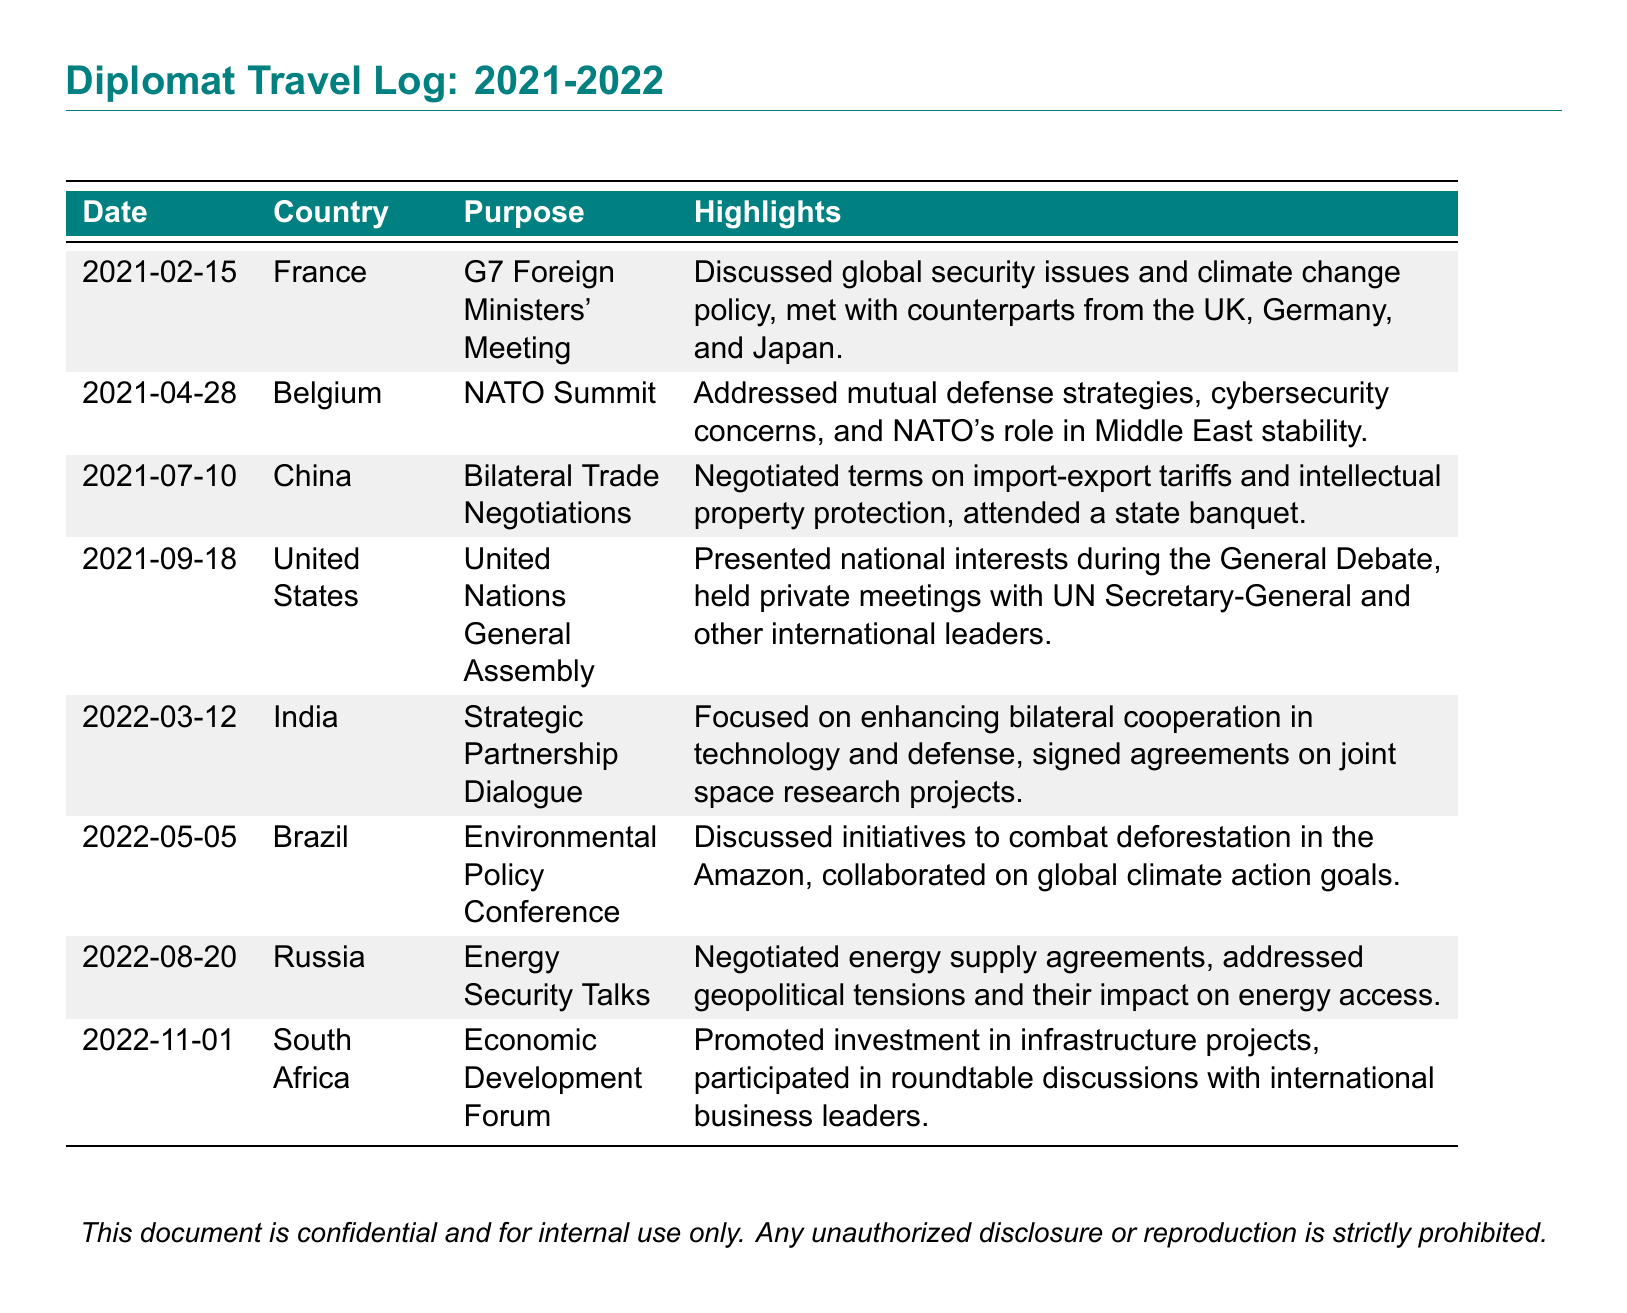What was the date of the G7 Foreign Ministers' Meeting? The date is specified in the document as 2021-02-15.
Answer: 2021-02-15 Which country hosted the NATO Summit? The document indicates that the NATO Summit was held in Belgium.
Answer: Belgium What was the main topic at the United Nations General Assembly? The highlights section states that national interests were presented during the General Debate.
Answer: National interests How many bilateral trade negotiations are mentioned? The document lists one instance of bilateral trade negotiations taking place in China.
Answer: One Which country was involved in the Strategic Partnership Dialogue? The document specifies that the dialogue was with India.
Answer: India What was one highlight of the Environmental Policy Conference? The document mentions that initiatives to combat deforestation in the Amazon were discussed.
Answer: Combating deforestation Which country was visited for energy security talks? The document states that energy security talks took place in Russia.
Answer: Russia What year was the Economic Development Forum held? The document indicates that the forum was held in 2022.
Answer: 2022 How many total visits to countries are documented? The document lists a total of eight visits to various countries.
Answer: Eight 